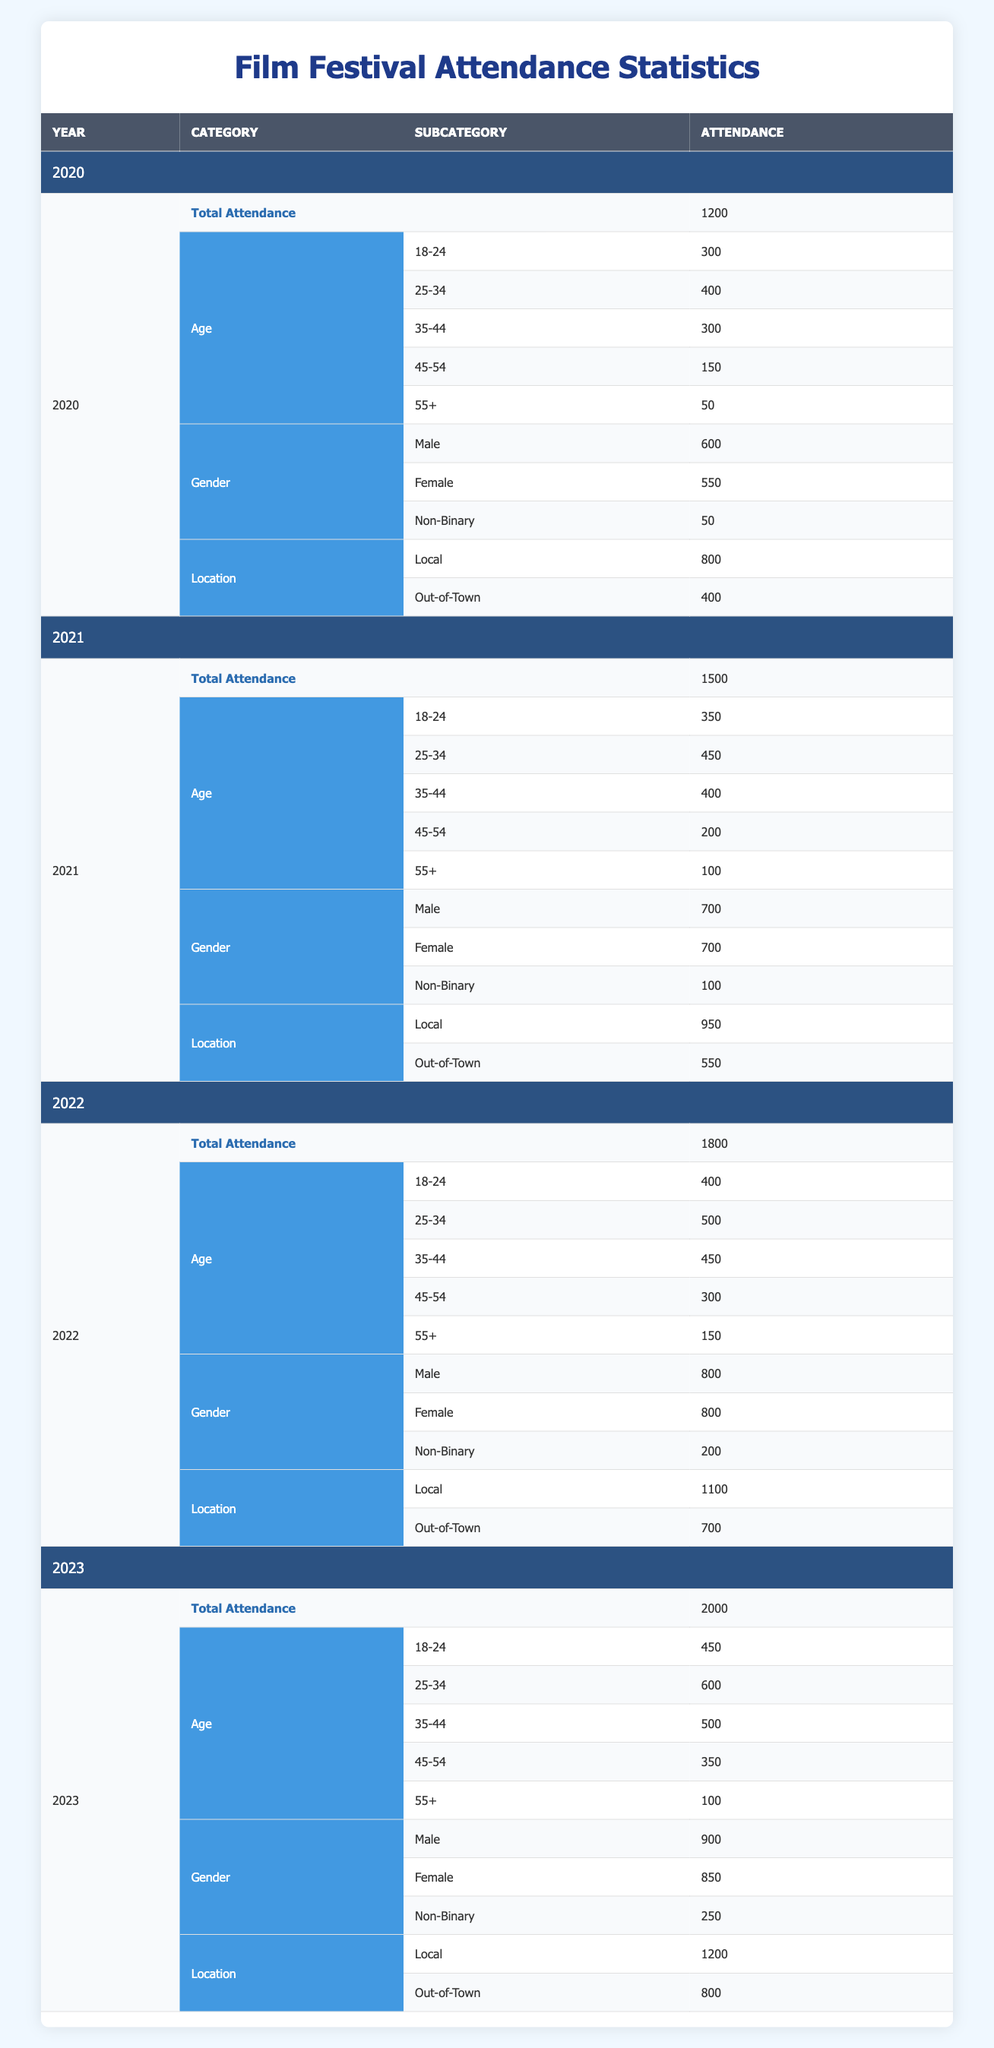What was the total attendance for the film festival in 2021? The total attendance for the film festival in 2021 is listed under the "Total Attendance" row for the year 2021, which shows a value of 1500.
Answer: 1500 How many attendees were local in 2022? For the year 2022, the number of local attendees is found under the "Location" demographic category, which indicates there were 1100 local attendees.
Answer: 1100 What is the percentage increase in total attendance from 2020 to 2023? The total attendance in 2020 was 1200 and in 2023 it was 2000. The increase is 2000 - 1200 = 800. To find the percentage increase, divide the increase by the original attendance and multiply by 100: (800 / 1200) * 100 = 66.67%.
Answer: 66.67% Did the number of female attendees exceed the number of non-binary attendees in 2022? In 2022, there were 800 female attendees and 200 non-binary attendees. Since 800 is greater than 200, the statement is true.
Answer: Yes In which year did the 25-34 age group have the highest attendance? Checking the attendance for the 25-34 age group across all years: 400 in 2020, 450 in 2021, 500 in 2022, and 600 in 2023. The highest attendance was in 2023 with 600 attendees.
Answer: 2023 What is the total number of attendees from the age group 55+ across all years? By summing the values for the 55+ age group in each year: 50 (2020) + 100 (2021) + 150 (2022) + 100 (2023) = 400, thus the total is 400.
Answer: 400 How many more males attended than females in 2021? In 2021, there were 700 males and 700 females. The difference between males and females is 700 - 700 = 0.
Answer: 0 What demographic category had the highest attendance in 2020? The highest attendance in 2020 was in the "Gender" category, with 600 male attendees, compared to the other demographic categories for that year.
Answer: Gender Which year saw the lowest attendance in the age group 45-54? Looking at the 45-54 age group across the years: 150 in 2020, 200 in 2021, 300 in 2022, and 350 in 2023. The lowest attendance was 150 in 2020.
Answer: 2020 